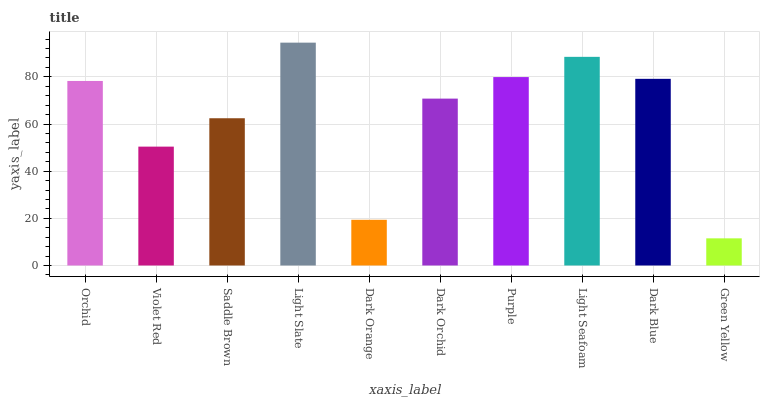Is Green Yellow the minimum?
Answer yes or no. Yes. Is Light Slate the maximum?
Answer yes or no. Yes. Is Violet Red the minimum?
Answer yes or no. No. Is Violet Red the maximum?
Answer yes or no. No. Is Orchid greater than Violet Red?
Answer yes or no. Yes. Is Violet Red less than Orchid?
Answer yes or no. Yes. Is Violet Red greater than Orchid?
Answer yes or no. No. Is Orchid less than Violet Red?
Answer yes or no. No. Is Orchid the high median?
Answer yes or no. Yes. Is Dark Orchid the low median?
Answer yes or no. Yes. Is Dark Orange the high median?
Answer yes or no. No. Is Purple the low median?
Answer yes or no. No. 